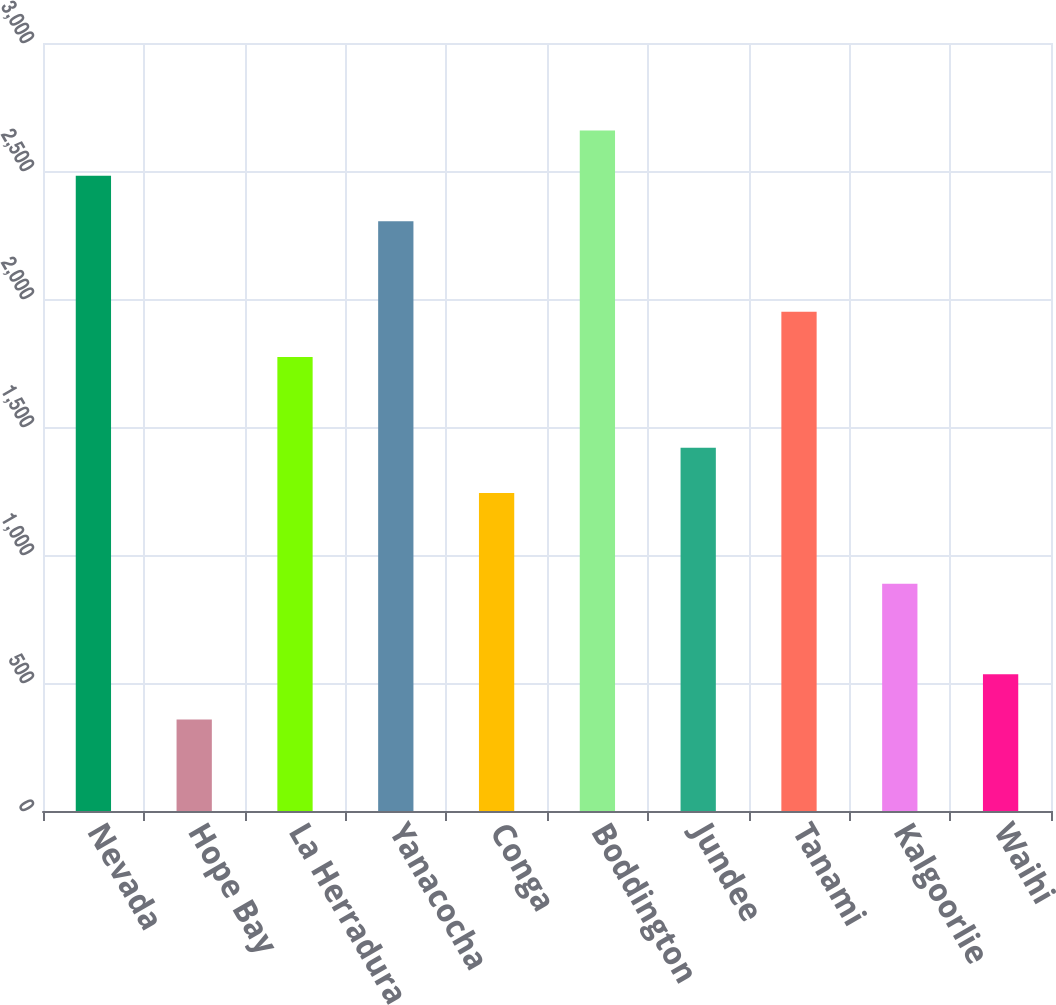<chart> <loc_0><loc_0><loc_500><loc_500><bar_chart><fcel>Nevada<fcel>Hope Bay<fcel>La Herradura<fcel>Yanacocha<fcel>Conga<fcel>Boddington<fcel>Jundee<fcel>Tanami<fcel>Kalgoorlie<fcel>Waihi<nl><fcel>2481<fcel>357<fcel>1773<fcel>2304<fcel>1242<fcel>2658<fcel>1419<fcel>1950<fcel>888<fcel>534<nl></chart> 